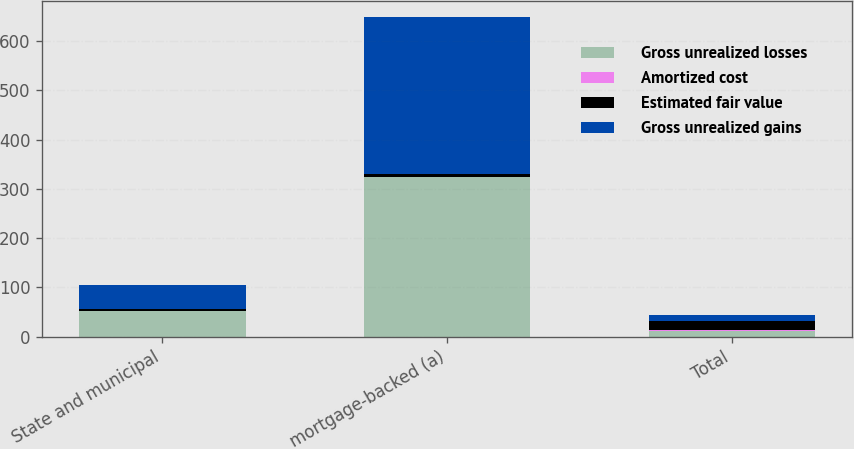<chart> <loc_0><loc_0><loc_500><loc_500><stacked_bar_chart><ecel><fcel>State and municipal<fcel>mortgage-backed (a)<fcel>Total<nl><fcel>Gross unrealized losses<fcel>51<fcel>323<fcel>12<nl><fcel>Amortized cost<fcel>1<fcel>1<fcel>2<nl><fcel>Estimated fair value<fcel>3<fcel>7<fcel>17<nl><fcel>Gross unrealized gains<fcel>49<fcel>317<fcel>12<nl></chart> 